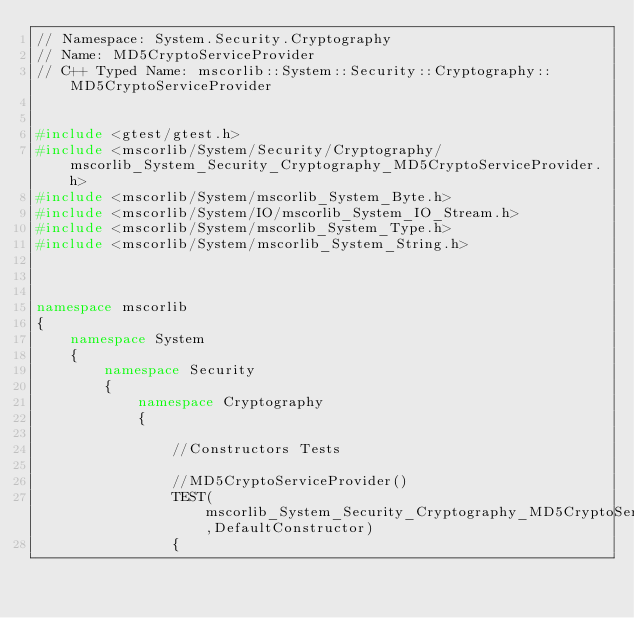<code> <loc_0><loc_0><loc_500><loc_500><_C++_>// Namespace: System.Security.Cryptography
// Name: MD5CryptoServiceProvider
// C++ Typed Name: mscorlib::System::Security::Cryptography::MD5CryptoServiceProvider


#include <gtest/gtest.h>
#include <mscorlib/System/Security/Cryptography/mscorlib_System_Security_Cryptography_MD5CryptoServiceProvider.h>
#include <mscorlib/System/mscorlib_System_Byte.h>
#include <mscorlib/System/IO/mscorlib_System_IO_Stream.h>
#include <mscorlib/System/mscorlib_System_Type.h>
#include <mscorlib/System/mscorlib_System_String.h>



namespace mscorlib
{
	namespace System
	{
		namespace Security
		{
			namespace Cryptography
			{

				//Constructors Tests
				
				//MD5CryptoServiceProvider()
				TEST(mscorlib_System_Security_Cryptography_MD5CryptoServiceProvider_Fixture,DefaultConstructor)
				{
					</code> 